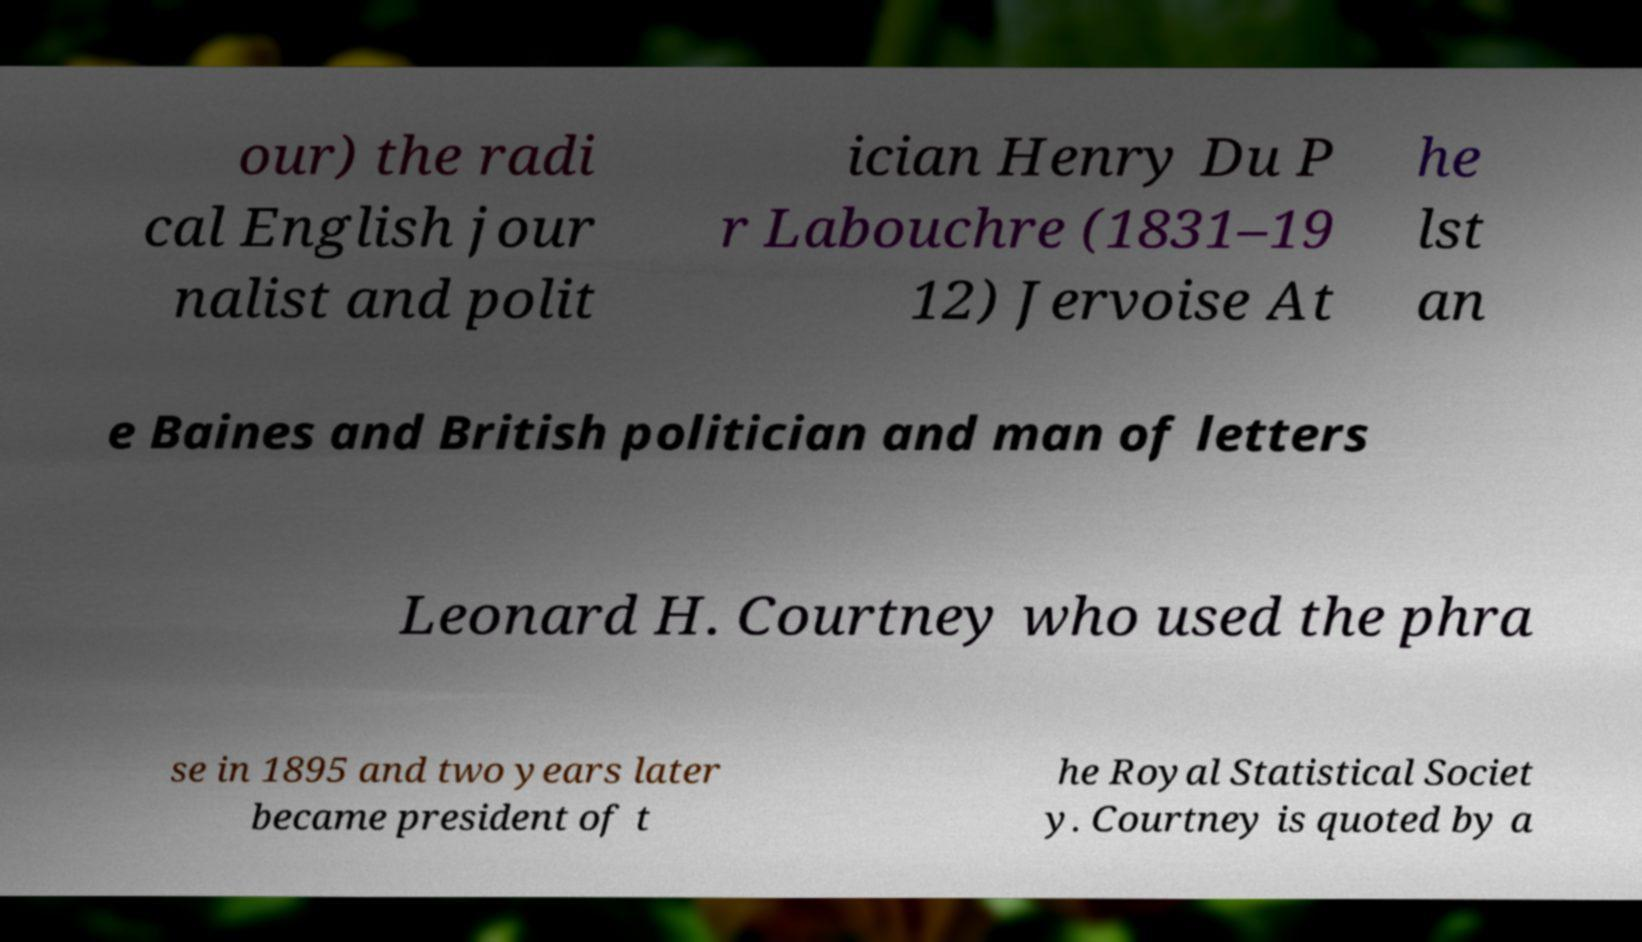Can you accurately transcribe the text from the provided image for me? our) the radi cal English jour nalist and polit ician Henry Du P r Labouchre (1831–19 12) Jervoise At he lst an e Baines and British politician and man of letters Leonard H. Courtney who used the phra se in 1895 and two years later became president of t he Royal Statistical Societ y. Courtney is quoted by a 